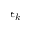<formula> <loc_0><loc_0><loc_500><loc_500>\epsilon _ { k }</formula> 